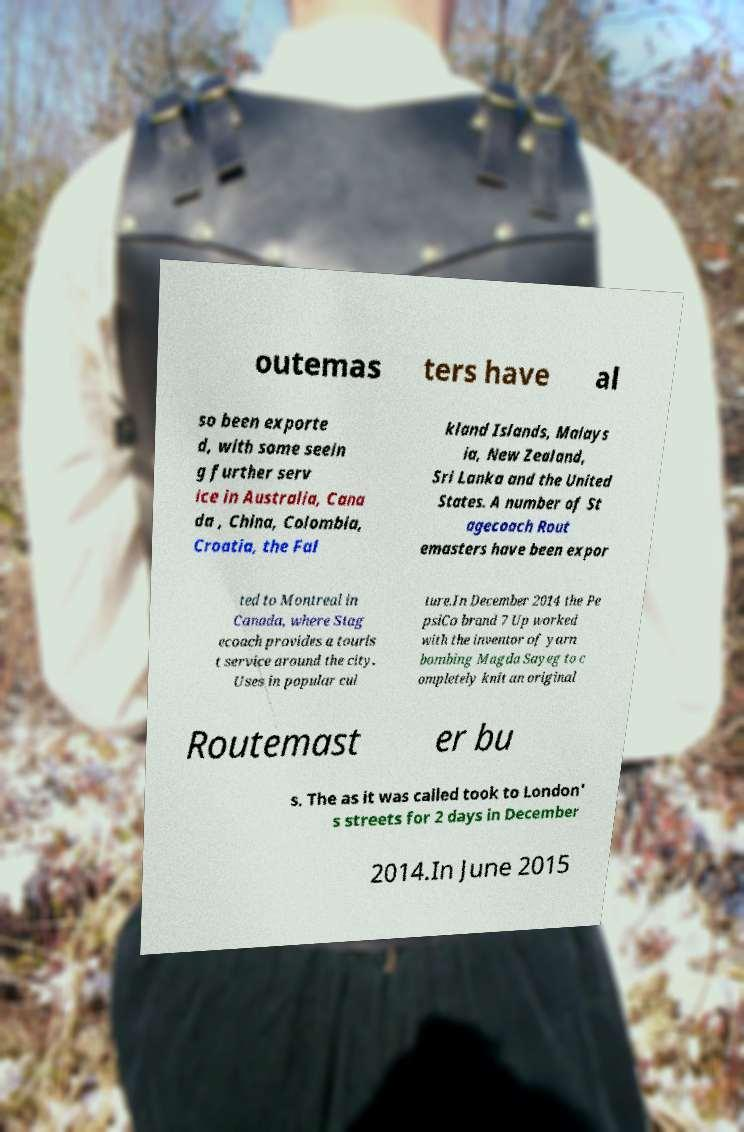Can you accurately transcribe the text from the provided image for me? outemas ters have al so been exporte d, with some seein g further serv ice in Australia, Cana da , China, Colombia, Croatia, the Fal kland Islands, Malays ia, New Zealand, Sri Lanka and the United States. A number of St agecoach Rout emasters have been expor ted to Montreal in Canada, where Stag ecoach provides a touris t service around the city. Uses in popular cul ture.In December 2014 the Pe psiCo brand 7 Up worked with the inventor of yarn bombing Magda Sayeg to c ompletely knit an original Routemast er bu s. The as it was called took to London' s streets for 2 days in December 2014.In June 2015 